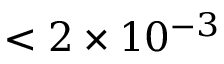Convert formula to latex. <formula><loc_0><loc_0><loc_500><loc_500>< 2 \times 1 0 ^ { - 3 }</formula> 